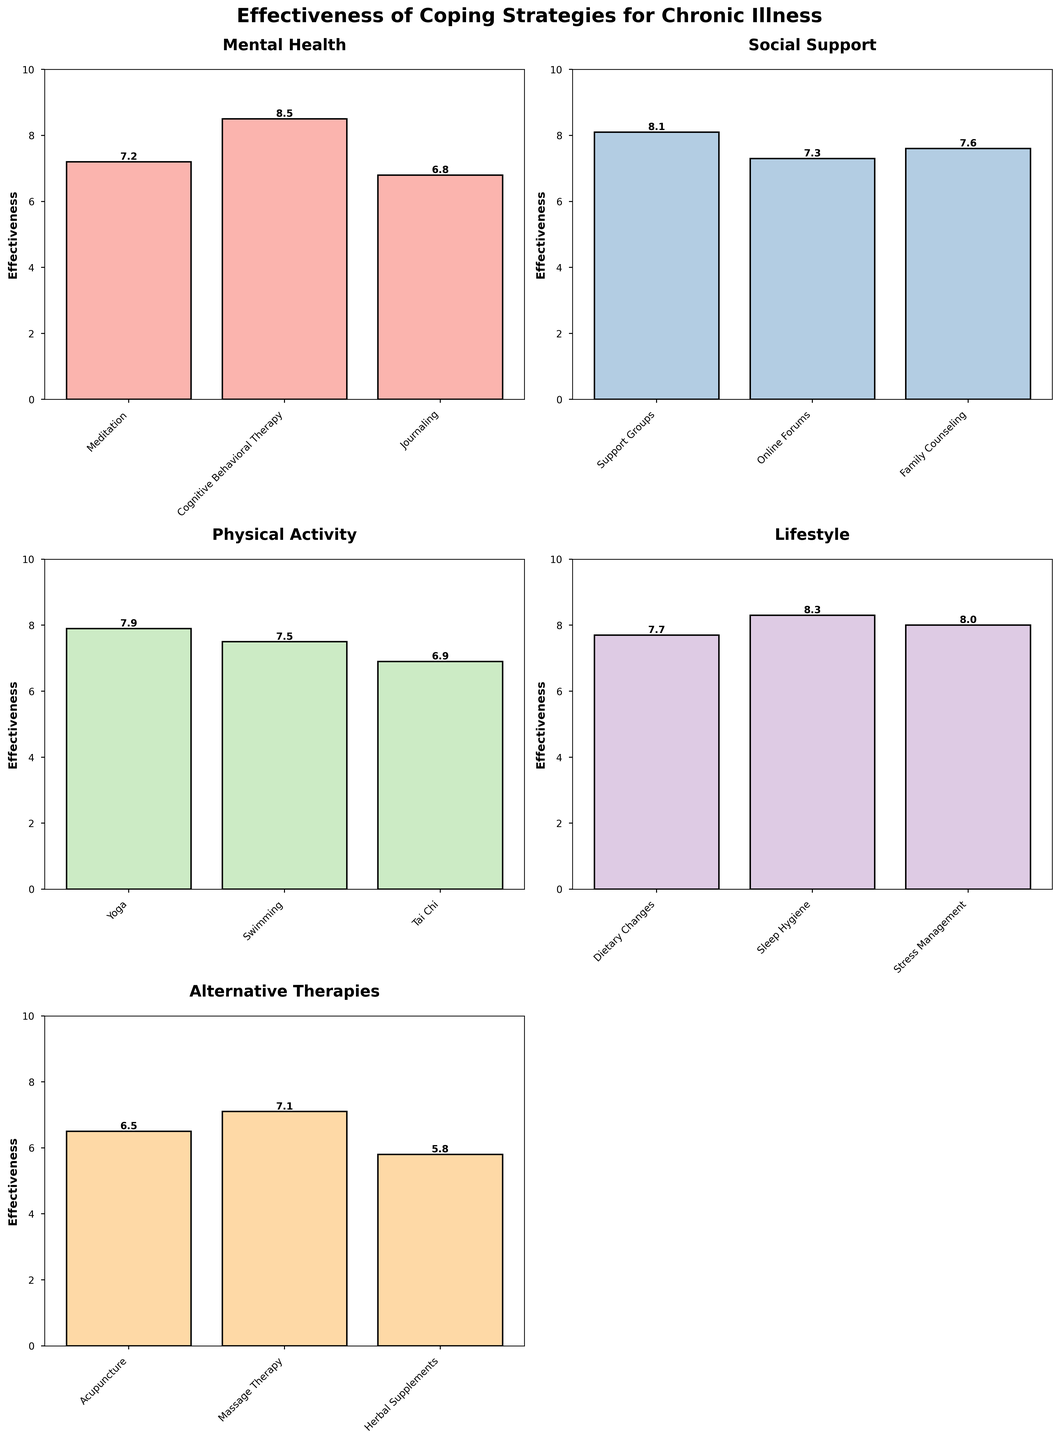How many strategy types are presented in this figure? The figure displays six subplots, each corresponding to a different strategy type.
Answer: Six What is the highest effectiveness rating in the Mental Health category? In the Mental Health subplot, Cognitive Behavioral Therapy has the highest effectiveness rating of 8.5.
Answer: 8.5 Which category has the lowest-rated coping strategy, and what is its effectiveness rating? By examining each subplot, Alternative Therapies has the lowest-rated coping strategy, Herbal Supplements, with an effectiveness of 5.8.
Answer: Alternative Therapies with 5.8 What is the average effectiveness rating of strategies within the Social Support category? The effectiveness ratings for Social Support are 8.1, 7.3, and 7.6. Adding these together gives 23, and dividing by 3 gets an average of 7.7.
Answer: 7.7 Which coping strategy has the highest overall effectiveness rating? Scanning across all subplots, Cognitive Behavioral Therapy in the Mental Health category has the highest rating of 8.5.
Answer: Cognitive Behavioral Therapy Compare the effectiveness of Yoga and Swimming. Which one is higher, and by how much? Yoga has an effectiveness rating of 7.9 while Swimming has 7.5. The difference is 7.9 - 7.5 = 0.4.
Answer: Yoga is higher by 0.4 What are the three most effective coping strategies across all categories? Across all subplots, the highest-rated strategies are Cognitive Behavioral Therapy (8.5), Sleep Hygiene (8.3), and Support Groups (8.1).
Answer: Cognitive Behavioral Therapy, Sleep Hygiene, Support Groups What is the total effectiveness rating of all coping strategies within the Physical Activity category? The effectiveness ratings for Physical Activity are 7.9, 7.5, and 6.9. The total is 7.9 + 7.5 + 6.9 = 22.3.
Answer: 22.3 How many bars have an effectiveness rating of 8.0 or higher? There are four bars with ratings of 8.0 or higher: Cognitive Behavioral Therapy, Support Groups, Sleep Hygiene, and Stress Management.
Answer: Four 